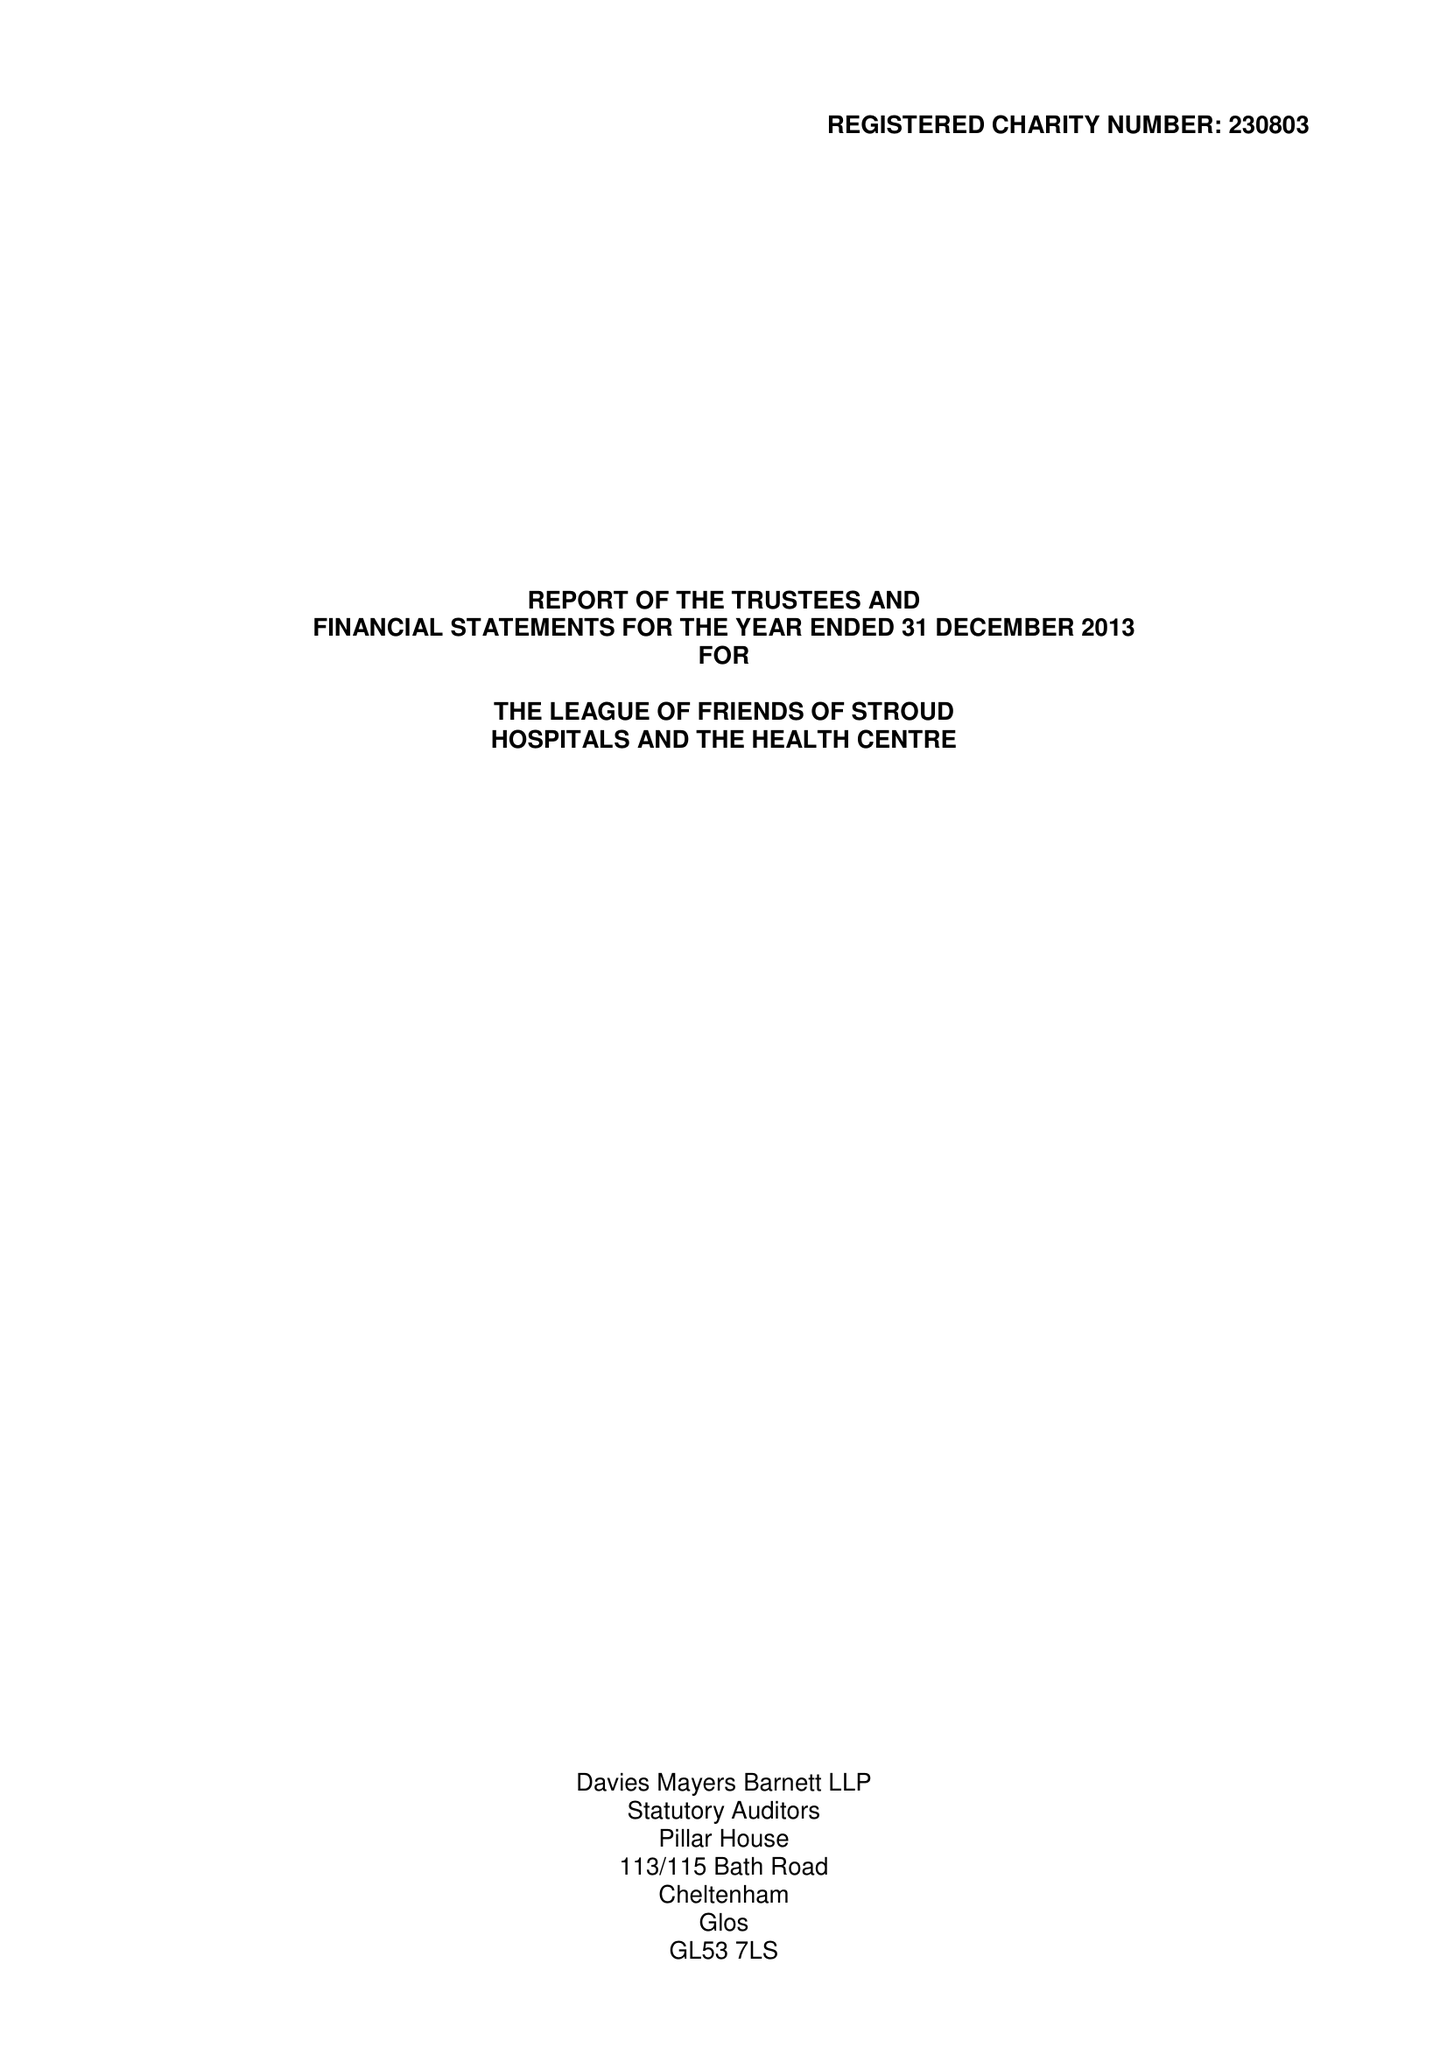What is the value for the address__street_line?
Answer the question using a single word or phrase. None 